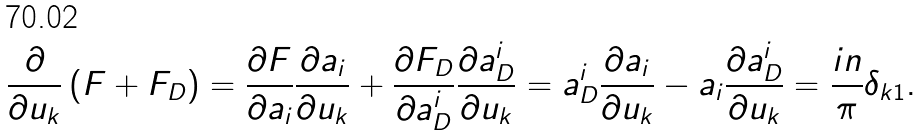<formula> <loc_0><loc_0><loc_500><loc_500>\frac { \partial } { \partial u _ { k } } \left ( F + F _ { D } \right ) = \frac { \partial F } { \partial a _ { i } } \frac { \partial a _ { i } } { \partial u _ { k } } + \frac { \partial F _ { D } } { \partial a _ { D } ^ { i } } \frac { \partial a _ { D } ^ { i } } { \partial u _ { k } } = a _ { D } ^ { i } \frac { \partial a _ { i } } { \partial u _ { k } } - a _ { i } \frac { \partial a _ { D } ^ { i } } { \partial u _ { k } } = \frac { i n } { \pi } \delta _ { k 1 } .</formula> 